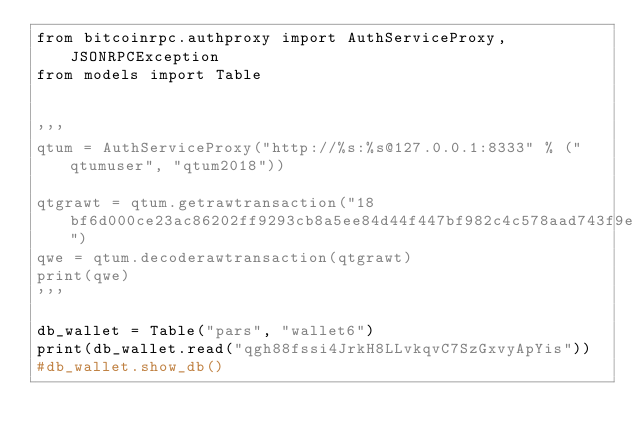Convert code to text. <code><loc_0><loc_0><loc_500><loc_500><_Python_>from bitcoinrpc.authproxy import AuthServiceProxy, JSONRPCException
from models import Table


'''
qtum = AuthServiceProxy("http://%s:%s@127.0.0.1:8333" % ("qtumuser", "qtum2018"))

qtgrawt = qtum.getrawtransaction("18bf6d000ce23ac86202ff9293cb8a5ee84d44f447bf982c4c578aad743f9eb9")
qwe = qtum.decoderawtransaction(qtgrawt)
print(qwe)
'''

db_wallet = Table("pars", "wallet6")
print(db_wallet.read("qgh88fssi4JrkH8LLvkqvC7SzGxvyApYis"))
#db_wallet.show_db()
</code> 